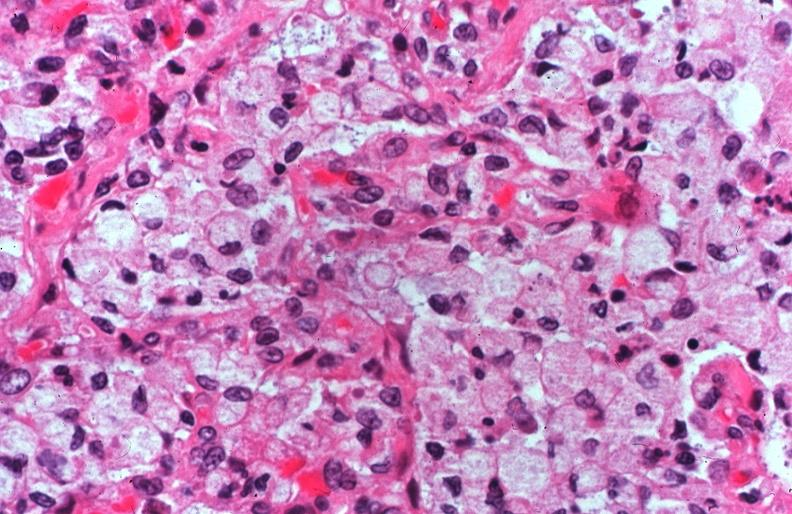does this typical thecoma with yellow foci show lung, cystic fibrosis?
Answer the question using a single word or phrase. No 